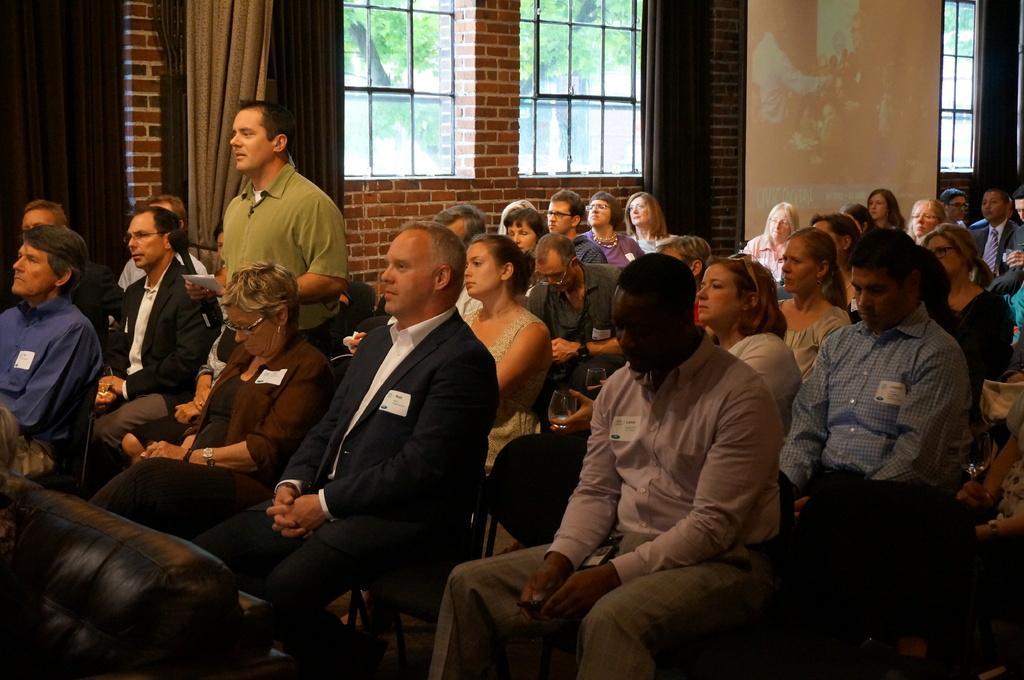Describe this image in one or two sentences. In this image I can see number of people where one is standing and rest all are sitting on chairs. I can see most of them are wearing shirt and blazers. In the background I can see windows, curtains and trees. 